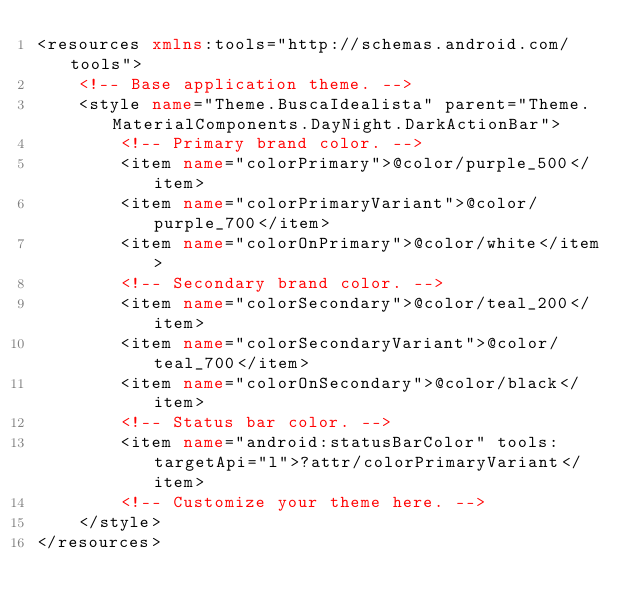<code> <loc_0><loc_0><loc_500><loc_500><_XML_><resources xmlns:tools="http://schemas.android.com/tools">
    <!-- Base application theme. -->
    <style name="Theme.BuscaIdealista" parent="Theme.MaterialComponents.DayNight.DarkActionBar">
        <!-- Primary brand color. -->
        <item name="colorPrimary">@color/purple_500</item>
        <item name="colorPrimaryVariant">@color/purple_700</item>
        <item name="colorOnPrimary">@color/white</item>
        <!-- Secondary brand color. -->
        <item name="colorSecondary">@color/teal_200</item>
        <item name="colorSecondaryVariant">@color/teal_700</item>
        <item name="colorOnSecondary">@color/black</item>
        <!-- Status bar color. -->
        <item name="android:statusBarColor" tools:targetApi="l">?attr/colorPrimaryVariant</item>
        <!-- Customize your theme here. -->
    </style>
</resources></code> 